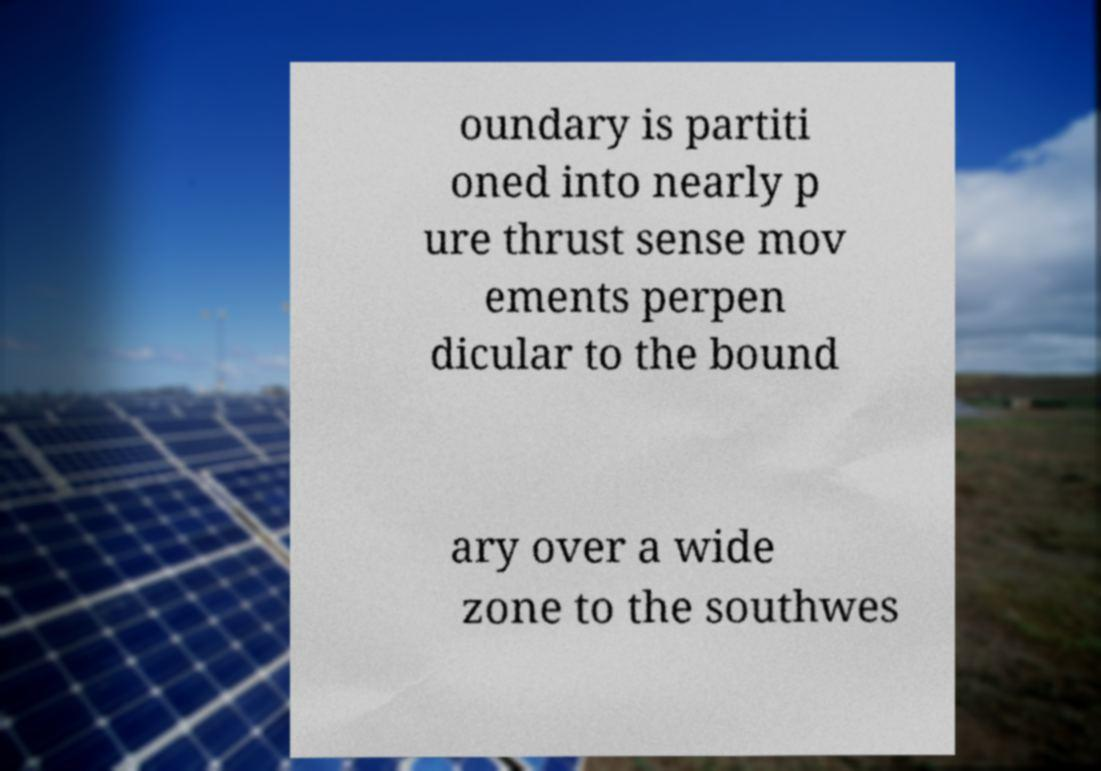I need the written content from this picture converted into text. Can you do that? oundary is partiti oned into nearly p ure thrust sense mov ements perpen dicular to the bound ary over a wide zone to the southwes 